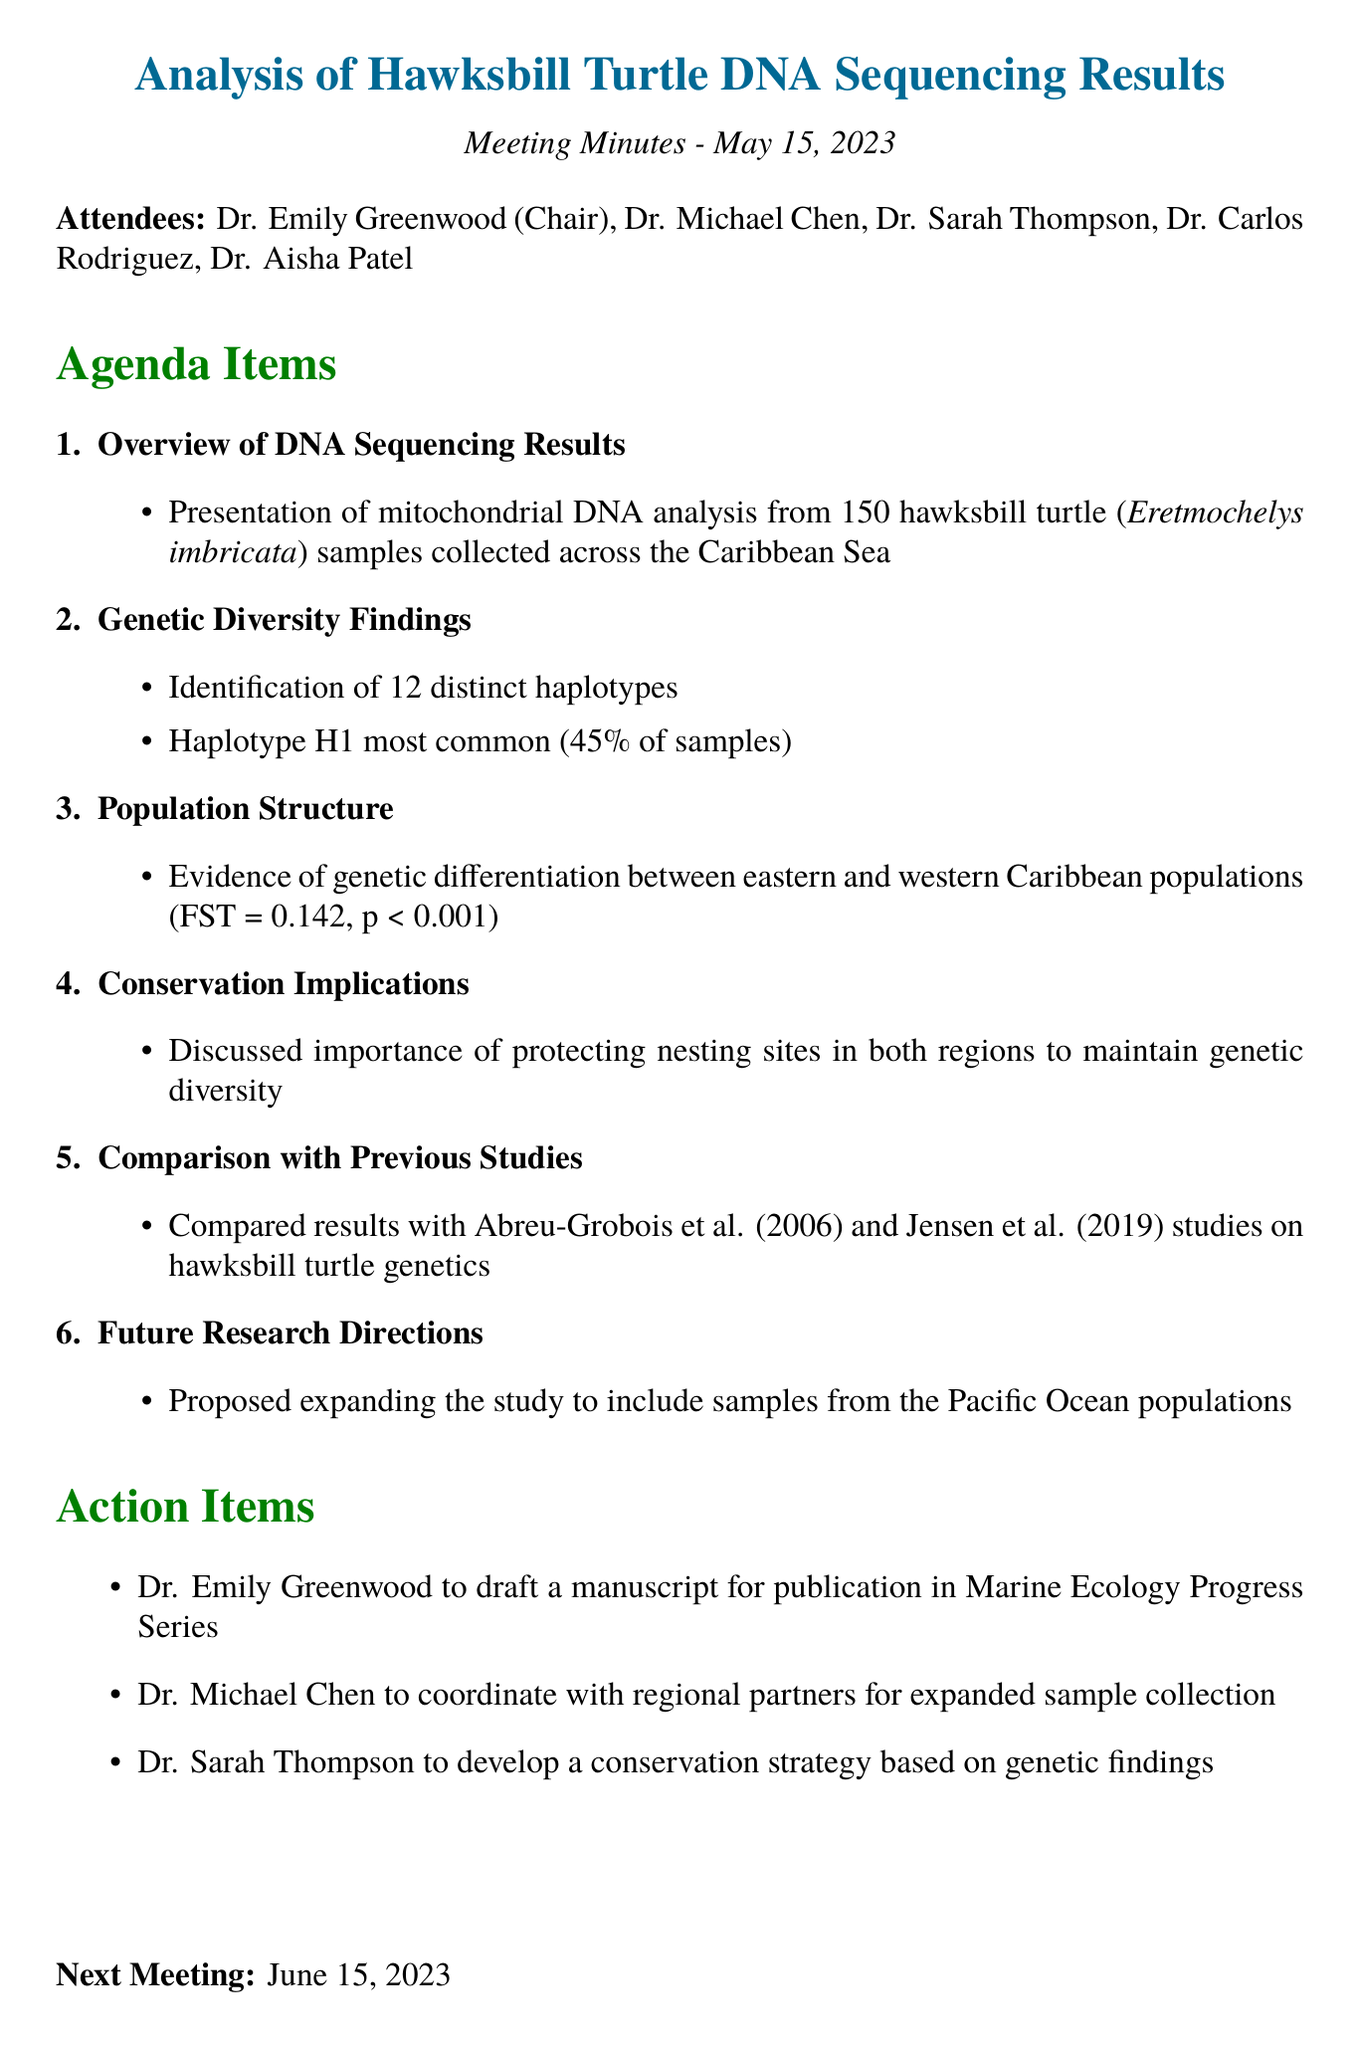What is the meeting date? The meeting date is explicitly mentioned in the document as "2023-05-15."
Answer: 2023-05-15 Who chaired the meeting? The document lists Dr. Emily Greenwood as the Chair of the meeting.
Answer: Dr. Emily Greenwood How many haplotypes were identified? The document states that 12 distinct haplotypes were identified in the study.
Answer: 12 What is the most common haplotype percentage? According to the document, haplotype H1 accounts for 45% of the samples.
Answer: 45% What is the FST value indicating genetic differentiation? The document specifies the FST value as 0.142, which suggests genetic differentiation.
Answer: 0.142 What is the primary conservation implication discussed? The meeting discussed the importance of protecting nesting sites in both regions.
Answer: Protecting nesting sites How did this study's findings compare to previous studies? The document mentions a comparison with studies by Abreu-Grobois et al. (2006) and Jensen et al. (2019).
Answer: Abreu-Grobois et al. (2006) and Jensen et al. (2019) What is the future research direction proposed? The document proposes expanding the study to include samples from Pacific Ocean populations.
Answer: Pacific Ocean populations When is the next meeting scheduled? The document states that the next meeting is scheduled for June 15, 2023.
Answer: June 15, 2023 